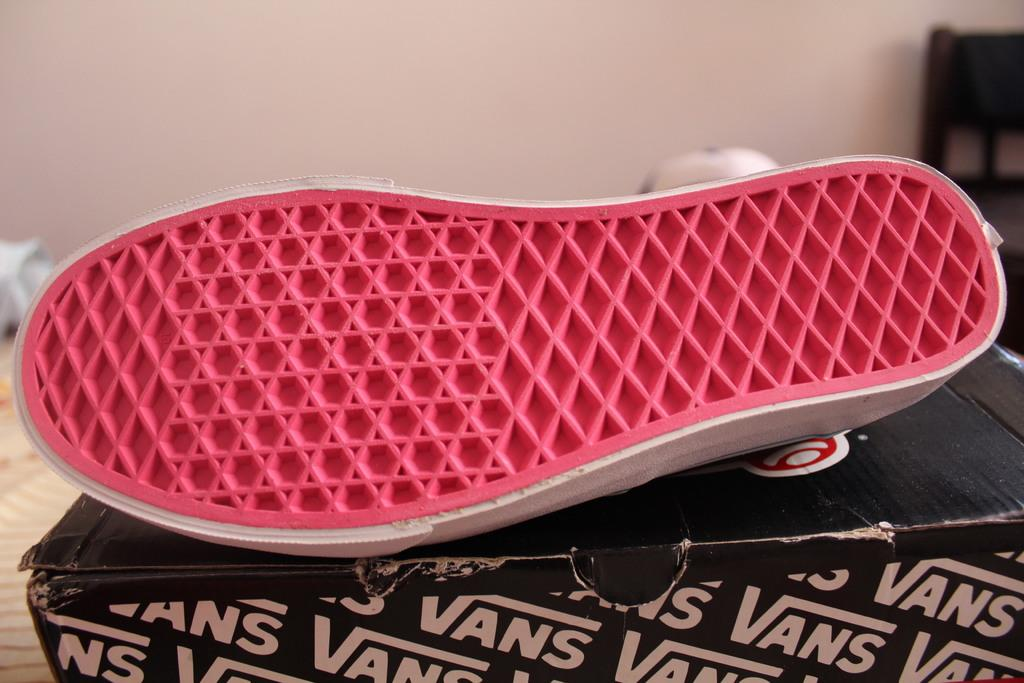What is placed on the box in the center of the image? There is a shoe placed on a box in the center of the image. What can be seen in the background of the image? There is a wall and a chair in the background of the image. What type of soup is being served in the image? There is no soup present in the image. What time of day is it in the image, considering the afternoon? The time of day cannot be determined from the image, as there are no clues or context provided to suggest a specific time. 